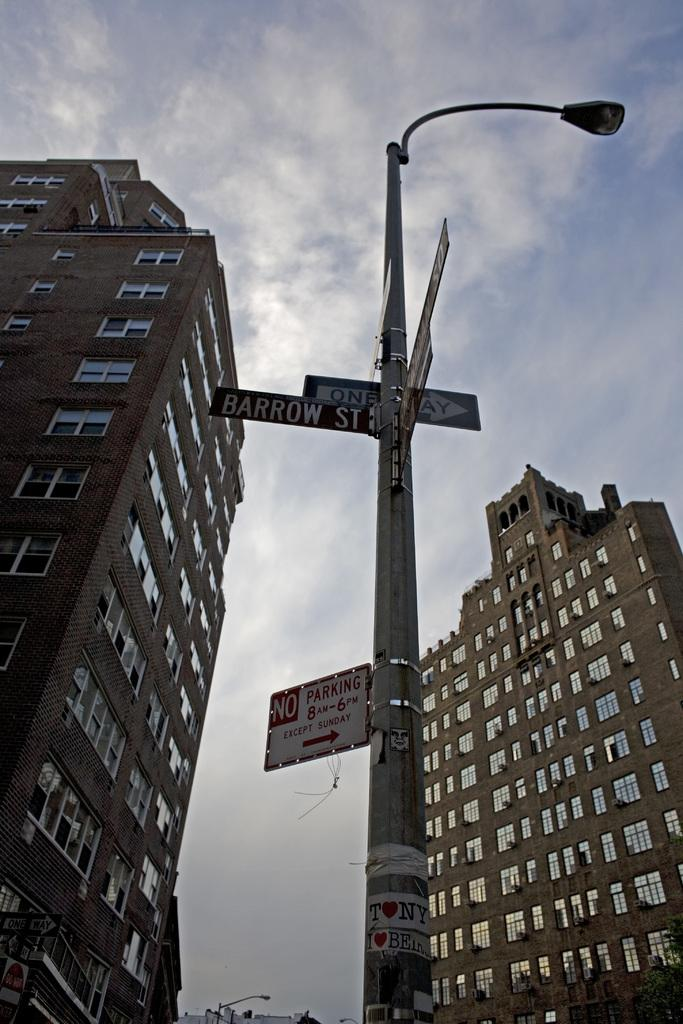What type of structures can be seen in the image? There are buildings in the image. What type of lighting is present in the image? There is a street light in the image. What type of information might be conveyed by the sign boards in the image? The sign boards in the image might convey information such as directions, advertisements, or warnings. What is visible at the top of the image? The sky is visible at the top of the image. What type of vessel is floating in the sky in the image? There is no vessel floating in the sky in the image; only buildings, a street light, sign boards, and the sky are present. 